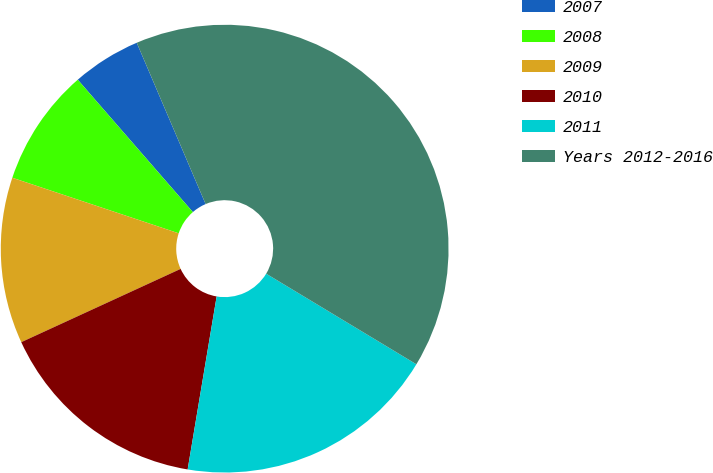Convert chart. <chart><loc_0><loc_0><loc_500><loc_500><pie_chart><fcel>2007<fcel>2008<fcel>2009<fcel>2010<fcel>2011<fcel>Years 2012-2016<nl><fcel>4.97%<fcel>8.48%<fcel>11.99%<fcel>15.5%<fcel>19.01%<fcel>40.07%<nl></chart> 